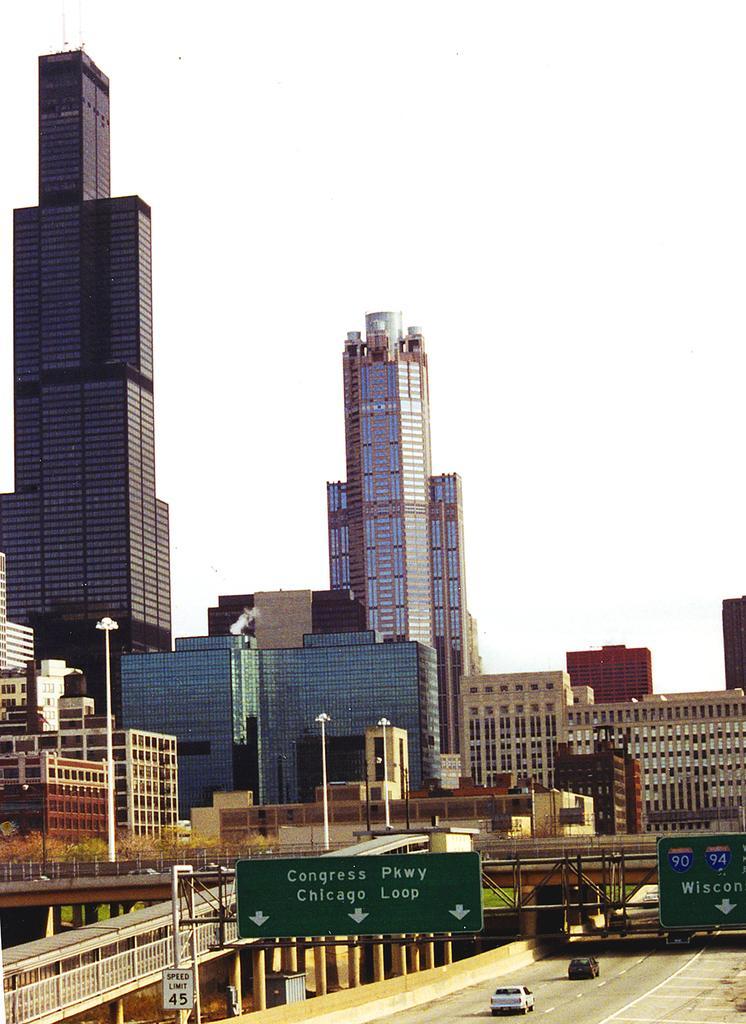Please provide a concise description of this image. In this picture I can see the tower buildings. I can see the buildings. I can see the vehicles on the road. I can see the bridges. 